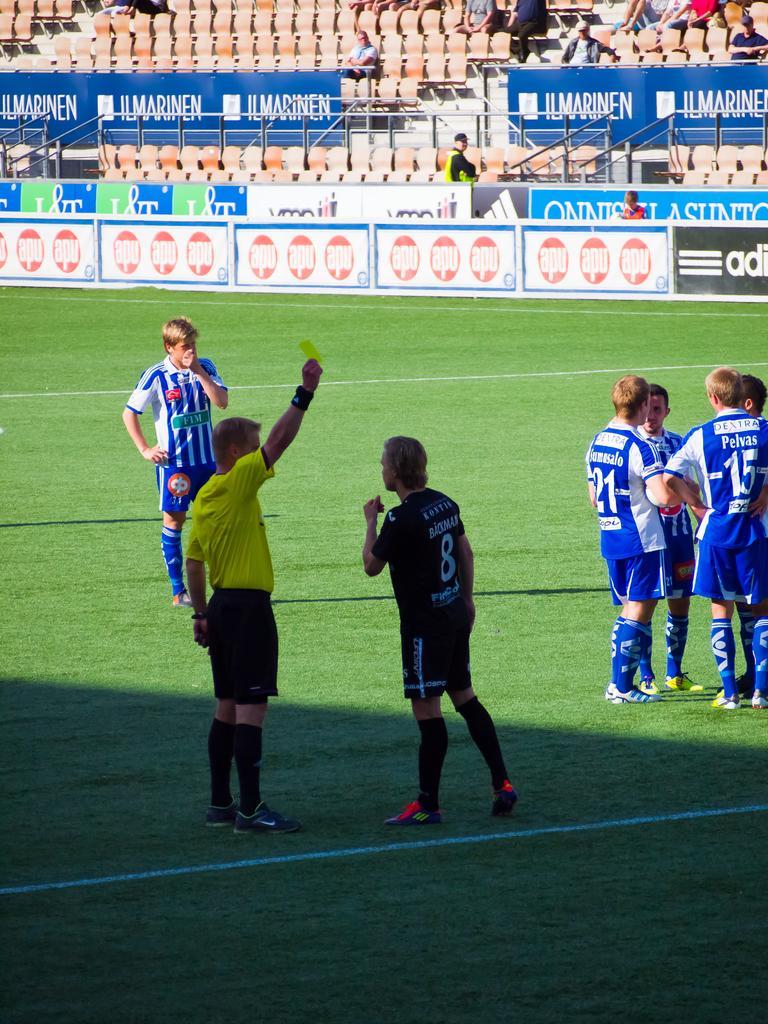How would you summarize this image in a sentence or two? There are group of people wearing blue dress is standing in ground and there is a person wearing black dress is standing in front of referee who is showing yellow card. 